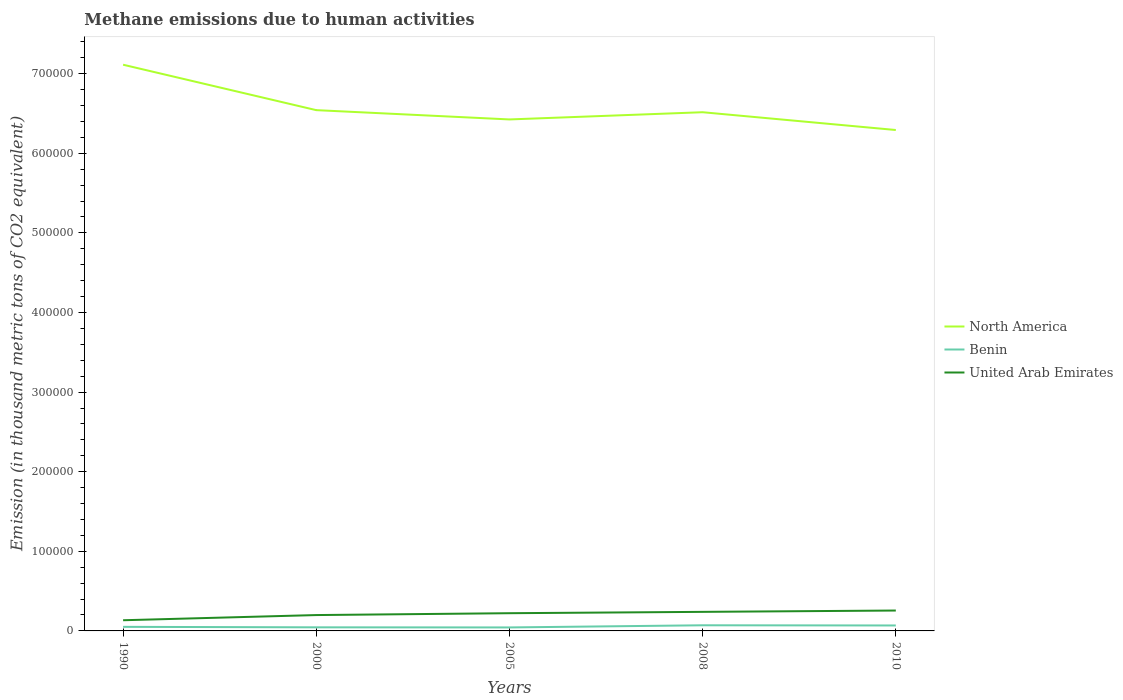How many different coloured lines are there?
Keep it short and to the point. 3. Does the line corresponding to United Arab Emirates intersect with the line corresponding to North America?
Keep it short and to the point. No. Is the number of lines equal to the number of legend labels?
Ensure brevity in your answer.  Yes. Across all years, what is the maximum amount of methane emitted in North America?
Provide a short and direct response. 6.29e+05. What is the total amount of methane emitted in United Arab Emirates in the graph?
Your response must be concise. -4025.9. What is the difference between the highest and the second highest amount of methane emitted in Benin?
Offer a terse response. 2709.3. What is the difference between the highest and the lowest amount of methane emitted in North America?
Your response must be concise. 1. How many lines are there?
Your response must be concise. 3. What is the difference between two consecutive major ticks on the Y-axis?
Give a very brief answer. 1.00e+05. Does the graph contain any zero values?
Offer a terse response. No. How are the legend labels stacked?
Provide a short and direct response. Vertical. What is the title of the graph?
Offer a very short reply. Methane emissions due to human activities. Does "Turkmenistan" appear as one of the legend labels in the graph?
Offer a terse response. No. What is the label or title of the X-axis?
Your response must be concise. Years. What is the label or title of the Y-axis?
Offer a terse response. Emission (in thousand metric tons of CO2 equivalent). What is the Emission (in thousand metric tons of CO2 equivalent) in North America in 1990?
Give a very brief answer. 7.11e+05. What is the Emission (in thousand metric tons of CO2 equivalent) in Benin in 1990?
Offer a very short reply. 5119.5. What is the Emission (in thousand metric tons of CO2 equivalent) of United Arab Emirates in 1990?
Make the answer very short. 1.34e+04. What is the Emission (in thousand metric tons of CO2 equivalent) of North America in 2000?
Your response must be concise. 6.54e+05. What is the Emission (in thousand metric tons of CO2 equivalent) in Benin in 2000?
Offer a very short reply. 4503.8. What is the Emission (in thousand metric tons of CO2 equivalent) in United Arab Emirates in 2000?
Your answer should be compact. 1.99e+04. What is the Emission (in thousand metric tons of CO2 equivalent) of North America in 2005?
Make the answer very short. 6.42e+05. What is the Emission (in thousand metric tons of CO2 equivalent) in Benin in 2005?
Your answer should be very brief. 4377.3. What is the Emission (in thousand metric tons of CO2 equivalent) of United Arab Emirates in 2005?
Keep it short and to the point. 2.23e+04. What is the Emission (in thousand metric tons of CO2 equivalent) of North America in 2008?
Offer a very short reply. 6.52e+05. What is the Emission (in thousand metric tons of CO2 equivalent) in Benin in 2008?
Offer a terse response. 7086.6. What is the Emission (in thousand metric tons of CO2 equivalent) of United Arab Emirates in 2008?
Offer a very short reply. 2.39e+04. What is the Emission (in thousand metric tons of CO2 equivalent) in North America in 2010?
Your answer should be compact. 6.29e+05. What is the Emission (in thousand metric tons of CO2 equivalent) of Benin in 2010?
Give a very brief answer. 6845.6. What is the Emission (in thousand metric tons of CO2 equivalent) of United Arab Emirates in 2010?
Your answer should be compact. 2.56e+04. Across all years, what is the maximum Emission (in thousand metric tons of CO2 equivalent) in North America?
Provide a short and direct response. 7.11e+05. Across all years, what is the maximum Emission (in thousand metric tons of CO2 equivalent) in Benin?
Make the answer very short. 7086.6. Across all years, what is the maximum Emission (in thousand metric tons of CO2 equivalent) of United Arab Emirates?
Keep it short and to the point. 2.56e+04. Across all years, what is the minimum Emission (in thousand metric tons of CO2 equivalent) of North America?
Keep it short and to the point. 6.29e+05. Across all years, what is the minimum Emission (in thousand metric tons of CO2 equivalent) in Benin?
Ensure brevity in your answer.  4377.3. Across all years, what is the minimum Emission (in thousand metric tons of CO2 equivalent) in United Arab Emirates?
Your response must be concise. 1.34e+04. What is the total Emission (in thousand metric tons of CO2 equivalent) of North America in the graph?
Provide a short and direct response. 3.29e+06. What is the total Emission (in thousand metric tons of CO2 equivalent) in Benin in the graph?
Your answer should be compact. 2.79e+04. What is the total Emission (in thousand metric tons of CO2 equivalent) of United Arab Emirates in the graph?
Offer a very short reply. 1.05e+05. What is the difference between the Emission (in thousand metric tons of CO2 equivalent) of North America in 1990 and that in 2000?
Your answer should be very brief. 5.71e+04. What is the difference between the Emission (in thousand metric tons of CO2 equivalent) of Benin in 1990 and that in 2000?
Provide a succinct answer. 615.7. What is the difference between the Emission (in thousand metric tons of CO2 equivalent) of United Arab Emirates in 1990 and that in 2000?
Offer a terse response. -6499. What is the difference between the Emission (in thousand metric tons of CO2 equivalent) in North America in 1990 and that in 2005?
Your response must be concise. 6.87e+04. What is the difference between the Emission (in thousand metric tons of CO2 equivalent) in Benin in 1990 and that in 2005?
Your answer should be very brief. 742.2. What is the difference between the Emission (in thousand metric tons of CO2 equivalent) of United Arab Emirates in 1990 and that in 2005?
Make the answer very short. -8841.4. What is the difference between the Emission (in thousand metric tons of CO2 equivalent) of North America in 1990 and that in 2008?
Give a very brief answer. 5.97e+04. What is the difference between the Emission (in thousand metric tons of CO2 equivalent) of Benin in 1990 and that in 2008?
Your answer should be compact. -1967.1. What is the difference between the Emission (in thousand metric tons of CO2 equivalent) in United Arab Emirates in 1990 and that in 2008?
Provide a short and direct response. -1.05e+04. What is the difference between the Emission (in thousand metric tons of CO2 equivalent) in North America in 1990 and that in 2010?
Give a very brief answer. 8.20e+04. What is the difference between the Emission (in thousand metric tons of CO2 equivalent) in Benin in 1990 and that in 2010?
Provide a short and direct response. -1726.1. What is the difference between the Emission (in thousand metric tons of CO2 equivalent) of United Arab Emirates in 1990 and that in 2010?
Ensure brevity in your answer.  -1.22e+04. What is the difference between the Emission (in thousand metric tons of CO2 equivalent) of North America in 2000 and that in 2005?
Provide a succinct answer. 1.17e+04. What is the difference between the Emission (in thousand metric tons of CO2 equivalent) in Benin in 2000 and that in 2005?
Your answer should be compact. 126.5. What is the difference between the Emission (in thousand metric tons of CO2 equivalent) in United Arab Emirates in 2000 and that in 2005?
Keep it short and to the point. -2342.4. What is the difference between the Emission (in thousand metric tons of CO2 equivalent) in North America in 2000 and that in 2008?
Make the answer very short. 2610. What is the difference between the Emission (in thousand metric tons of CO2 equivalent) in Benin in 2000 and that in 2008?
Offer a terse response. -2582.8. What is the difference between the Emission (in thousand metric tons of CO2 equivalent) of United Arab Emirates in 2000 and that in 2008?
Offer a terse response. -4025.9. What is the difference between the Emission (in thousand metric tons of CO2 equivalent) of North America in 2000 and that in 2010?
Your answer should be compact. 2.50e+04. What is the difference between the Emission (in thousand metric tons of CO2 equivalent) in Benin in 2000 and that in 2010?
Provide a succinct answer. -2341.8. What is the difference between the Emission (in thousand metric tons of CO2 equivalent) of United Arab Emirates in 2000 and that in 2010?
Provide a short and direct response. -5694.4. What is the difference between the Emission (in thousand metric tons of CO2 equivalent) in North America in 2005 and that in 2008?
Offer a very short reply. -9061.6. What is the difference between the Emission (in thousand metric tons of CO2 equivalent) of Benin in 2005 and that in 2008?
Make the answer very short. -2709.3. What is the difference between the Emission (in thousand metric tons of CO2 equivalent) of United Arab Emirates in 2005 and that in 2008?
Your response must be concise. -1683.5. What is the difference between the Emission (in thousand metric tons of CO2 equivalent) in North America in 2005 and that in 2010?
Your answer should be very brief. 1.33e+04. What is the difference between the Emission (in thousand metric tons of CO2 equivalent) in Benin in 2005 and that in 2010?
Provide a succinct answer. -2468.3. What is the difference between the Emission (in thousand metric tons of CO2 equivalent) in United Arab Emirates in 2005 and that in 2010?
Keep it short and to the point. -3352. What is the difference between the Emission (in thousand metric tons of CO2 equivalent) of North America in 2008 and that in 2010?
Provide a short and direct response. 2.23e+04. What is the difference between the Emission (in thousand metric tons of CO2 equivalent) of Benin in 2008 and that in 2010?
Ensure brevity in your answer.  241. What is the difference between the Emission (in thousand metric tons of CO2 equivalent) of United Arab Emirates in 2008 and that in 2010?
Offer a very short reply. -1668.5. What is the difference between the Emission (in thousand metric tons of CO2 equivalent) of North America in 1990 and the Emission (in thousand metric tons of CO2 equivalent) of Benin in 2000?
Ensure brevity in your answer.  7.07e+05. What is the difference between the Emission (in thousand metric tons of CO2 equivalent) of North America in 1990 and the Emission (in thousand metric tons of CO2 equivalent) of United Arab Emirates in 2000?
Provide a short and direct response. 6.91e+05. What is the difference between the Emission (in thousand metric tons of CO2 equivalent) of Benin in 1990 and the Emission (in thousand metric tons of CO2 equivalent) of United Arab Emirates in 2000?
Your answer should be very brief. -1.48e+04. What is the difference between the Emission (in thousand metric tons of CO2 equivalent) in North America in 1990 and the Emission (in thousand metric tons of CO2 equivalent) in Benin in 2005?
Provide a short and direct response. 7.07e+05. What is the difference between the Emission (in thousand metric tons of CO2 equivalent) in North America in 1990 and the Emission (in thousand metric tons of CO2 equivalent) in United Arab Emirates in 2005?
Offer a terse response. 6.89e+05. What is the difference between the Emission (in thousand metric tons of CO2 equivalent) in Benin in 1990 and the Emission (in thousand metric tons of CO2 equivalent) in United Arab Emirates in 2005?
Your answer should be very brief. -1.71e+04. What is the difference between the Emission (in thousand metric tons of CO2 equivalent) of North America in 1990 and the Emission (in thousand metric tons of CO2 equivalent) of Benin in 2008?
Keep it short and to the point. 7.04e+05. What is the difference between the Emission (in thousand metric tons of CO2 equivalent) of North America in 1990 and the Emission (in thousand metric tons of CO2 equivalent) of United Arab Emirates in 2008?
Your answer should be compact. 6.87e+05. What is the difference between the Emission (in thousand metric tons of CO2 equivalent) in Benin in 1990 and the Emission (in thousand metric tons of CO2 equivalent) in United Arab Emirates in 2008?
Your answer should be very brief. -1.88e+04. What is the difference between the Emission (in thousand metric tons of CO2 equivalent) in North America in 1990 and the Emission (in thousand metric tons of CO2 equivalent) in Benin in 2010?
Offer a very short reply. 7.04e+05. What is the difference between the Emission (in thousand metric tons of CO2 equivalent) in North America in 1990 and the Emission (in thousand metric tons of CO2 equivalent) in United Arab Emirates in 2010?
Offer a very short reply. 6.86e+05. What is the difference between the Emission (in thousand metric tons of CO2 equivalent) of Benin in 1990 and the Emission (in thousand metric tons of CO2 equivalent) of United Arab Emirates in 2010?
Offer a terse response. -2.05e+04. What is the difference between the Emission (in thousand metric tons of CO2 equivalent) of North America in 2000 and the Emission (in thousand metric tons of CO2 equivalent) of Benin in 2005?
Your response must be concise. 6.50e+05. What is the difference between the Emission (in thousand metric tons of CO2 equivalent) in North America in 2000 and the Emission (in thousand metric tons of CO2 equivalent) in United Arab Emirates in 2005?
Provide a succinct answer. 6.32e+05. What is the difference between the Emission (in thousand metric tons of CO2 equivalent) of Benin in 2000 and the Emission (in thousand metric tons of CO2 equivalent) of United Arab Emirates in 2005?
Offer a terse response. -1.78e+04. What is the difference between the Emission (in thousand metric tons of CO2 equivalent) in North America in 2000 and the Emission (in thousand metric tons of CO2 equivalent) in Benin in 2008?
Your response must be concise. 6.47e+05. What is the difference between the Emission (in thousand metric tons of CO2 equivalent) of North America in 2000 and the Emission (in thousand metric tons of CO2 equivalent) of United Arab Emirates in 2008?
Give a very brief answer. 6.30e+05. What is the difference between the Emission (in thousand metric tons of CO2 equivalent) in Benin in 2000 and the Emission (in thousand metric tons of CO2 equivalent) in United Arab Emirates in 2008?
Give a very brief answer. -1.94e+04. What is the difference between the Emission (in thousand metric tons of CO2 equivalent) of North America in 2000 and the Emission (in thousand metric tons of CO2 equivalent) of Benin in 2010?
Provide a short and direct response. 6.47e+05. What is the difference between the Emission (in thousand metric tons of CO2 equivalent) of North America in 2000 and the Emission (in thousand metric tons of CO2 equivalent) of United Arab Emirates in 2010?
Your response must be concise. 6.29e+05. What is the difference between the Emission (in thousand metric tons of CO2 equivalent) in Benin in 2000 and the Emission (in thousand metric tons of CO2 equivalent) in United Arab Emirates in 2010?
Your answer should be very brief. -2.11e+04. What is the difference between the Emission (in thousand metric tons of CO2 equivalent) of North America in 2005 and the Emission (in thousand metric tons of CO2 equivalent) of Benin in 2008?
Make the answer very short. 6.35e+05. What is the difference between the Emission (in thousand metric tons of CO2 equivalent) of North America in 2005 and the Emission (in thousand metric tons of CO2 equivalent) of United Arab Emirates in 2008?
Keep it short and to the point. 6.19e+05. What is the difference between the Emission (in thousand metric tons of CO2 equivalent) of Benin in 2005 and the Emission (in thousand metric tons of CO2 equivalent) of United Arab Emirates in 2008?
Keep it short and to the point. -1.96e+04. What is the difference between the Emission (in thousand metric tons of CO2 equivalent) of North America in 2005 and the Emission (in thousand metric tons of CO2 equivalent) of Benin in 2010?
Ensure brevity in your answer.  6.36e+05. What is the difference between the Emission (in thousand metric tons of CO2 equivalent) of North America in 2005 and the Emission (in thousand metric tons of CO2 equivalent) of United Arab Emirates in 2010?
Your response must be concise. 6.17e+05. What is the difference between the Emission (in thousand metric tons of CO2 equivalent) of Benin in 2005 and the Emission (in thousand metric tons of CO2 equivalent) of United Arab Emirates in 2010?
Ensure brevity in your answer.  -2.12e+04. What is the difference between the Emission (in thousand metric tons of CO2 equivalent) in North America in 2008 and the Emission (in thousand metric tons of CO2 equivalent) in Benin in 2010?
Ensure brevity in your answer.  6.45e+05. What is the difference between the Emission (in thousand metric tons of CO2 equivalent) of North America in 2008 and the Emission (in thousand metric tons of CO2 equivalent) of United Arab Emirates in 2010?
Your response must be concise. 6.26e+05. What is the difference between the Emission (in thousand metric tons of CO2 equivalent) in Benin in 2008 and the Emission (in thousand metric tons of CO2 equivalent) in United Arab Emirates in 2010?
Give a very brief answer. -1.85e+04. What is the average Emission (in thousand metric tons of CO2 equivalent) in North America per year?
Provide a short and direct response. 6.58e+05. What is the average Emission (in thousand metric tons of CO2 equivalent) of Benin per year?
Keep it short and to the point. 5586.56. What is the average Emission (in thousand metric tons of CO2 equivalent) in United Arab Emirates per year?
Your answer should be very brief. 2.10e+04. In the year 1990, what is the difference between the Emission (in thousand metric tons of CO2 equivalent) of North America and Emission (in thousand metric tons of CO2 equivalent) of Benin?
Give a very brief answer. 7.06e+05. In the year 1990, what is the difference between the Emission (in thousand metric tons of CO2 equivalent) of North America and Emission (in thousand metric tons of CO2 equivalent) of United Arab Emirates?
Provide a short and direct response. 6.98e+05. In the year 1990, what is the difference between the Emission (in thousand metric tons of CO2 equivalent) in Benin and Emission (in thousand metric tons of CO2 equivalent) in United Arab Emirates?
Offer a very short reply. -8294.7. In the year 2000, what is the difference between the Emission (in thousand metric tons of CO2 equivalent) in North America and Emission (in thousand metric tons of CO2 equivalent) in Benin?
Your answer should be compact. 6.50e+05. In the year 2000, what is the difference between the Emission (in thousand metric tons of CO2 equivalent) of North America and Emission (in thousand metric tons of CO2 equivalent) of United Arab Emirates?
Your answer should be very brief. 6.34e+05. In the year 2000, what is the difference between the Emission (in thousand metric tons of CO2 equivalent) in Benin and Emission (in thousand metric tons of CO2 equivalent) in United Arab Emirates?
Give a very brief answer. -1.54e+04. In the year 2005, what is the difference between the Emission (in thousand metric tons of CO2 equivalent) of North America and Emission (in thousand metric tons of CO2 equivalent) of Benin?
Ensure brevity in your answer.  6.38e+05. In the year 2005, what is the difference between the Emission (in thousand metric tons of CO2 equivalent) of North America and Emission (in thousand metric tons of CO2 equivalent) of United Arab Emirates?
Your response must be concise. 6.20e+05. In the year 2005, what is the difference between the Emission (in thousand metric tons of CO2 equivalent) in Benin and Emission (in thousand metric tons of CO2 equivalent) in United Arab Emirates?
Make the answer very short. -1.79e+04. In the year 2008, what is the difference between the Emission (in thousand metric tons of CO2 equivalent) of North America and Emission (in thousand metric tons of CO2 equivalent) of Benin?
Make the answer very short. 6.44e+05. In the year 2008, what is the difference between the Emission (in thousand metric tons of CO2 equivalent) in North America and Emission (in thousand metric tons of CO2 equivalent) in United Arab Emirates?
Offer a terse response. 6.28e+05. In the year 2008, what is the difference between the Emission (in thousand metric tons of CO2 equivalent) in Benin and Emission (in thousand metric tons of CO2 equivalent) in United Arab Emirates?
Ensure brevity in your answer.  -1.69e+04. In the year 2010, what is the difference between the Emission (in thousand metric tons of CO2 equivalent) of North America and Emission (in thousand metric tons of CO2 equivalent) of Benin?
Give a very brief answer. 6.22e+05. In the year 2010, what is the difference between the Emission (in thousand metric tons of CO2 equivalent) in North America and Emission (in thousand metric tons of CO2 equivalent) in United Arab Emirates?
Ensure brevity in your answer.  6.04e+05. In the year 2010, what is the difference between the Emission (in thousand metric tons of CO2 equivalent) of Benin and Emission (in thousand metric tons of CO2 equivalent) of United Arab Emirates?
Your answer should be very brief. -1.88e+04. What is the ratio of the Emission (in thousand metric tons of CO2 equivalent) of North America in 1990 to that in 2000?
Ensure brevity in your answer.  1.09. What is the ratio of the Emission (in thousand metric tons of CO2 equivalent) of Benin in 1990 to that in 2000?
Give a very brief answer. 1.14. What is the ratio of the Emission (in thousand metric tons of CO2 equivalent) in United Arab Emirates in 1990 to that in 2000?
Ensure brevity in your answer.  0.67. What is the ratio of the Emission (in thousand metric tons of CO2 equivalent) of North America in 1990 to that in 2005?
Offer a very short reply. 1.11. What is the ratio of the Emission (in thousand metric tons of CO2 equivalent) of Benin in 1990 to that in 2005?
Your answer should be very brief. 1.17. What is the ratio of the Emission (in thousand metric tons of CO2 equivalent) in United Arab Emirates in 1990 to that in 2005?
Provide a short and direct response. 0.6. What is the ratio of the Emission (in thousand metric tons of CO2 equivalent) of North America in 1990 to that in 2008?
Ensure brevity in your answer.  1.09. What is the ratio of the Emission (in thousand metric tons of CO2 equivalent) of Benin in 1990 to that in 2008?
Your answer should be very brief. 0.72. What is the ratio of the Emission (in thousand metric tons of CO2 equivalent) of United Arab Emirates in 1990 to that in 2008?
Provide a short and direct response. 0.56. What is the ratio of the Emission (in thousand metric tons of CO2 equivalent) in North America in 1990 to that in 2010?
Your answer should be compact. 1.13. What is the ratio of the Emission (in thousand metric tons of CO2 equivalent) in Benin in 1990 to that in 2010?
Your answer should be very brief. 0.75. What is the ratio of the Emission (in thousand metric tons of CO2 equivalent) in United Arab Emirates in 1990 to that in 2010?
Your answer should be very brief. 0.52. What is the ratio of the Emission (in thousand metric tons of CO2 equivalent) of North America in 2000 to that in 2005?
Offer a terse response. 1.02. What is the ratio of the Emission (in thousand metric tons of CO2 equivalent) of Benin in 2000 to that in 2005?
Give a very brief answer. 1.03. What is the ratio of the Emission (in thousand metric tons of CO2 equivalent) of United Arab Emirates in 2000 to that in 2005?
Make the answer very short. 0.89. What is the ratio of the Emission (in thousand metric tons of CO2 equivalent) in Benin in 2000 to that in 2008?
Ensure brevity in your answer.  0.64. What is the ratio of the Emission (in thousand metric tons of CO2 equivalent) in United Arab Emirates in 2000 to that in 2008?
Keep it short and to the point. 0.83. What is the ratio of the Emission (in thousand metric tons of CO2 equivalent) in North America in 2000 to that in 2010?
Offer a very short reply. 1.04. What is the ratio of the Emission (in thousand metric tons of CO2 equivalent) in Benin in 2000 to that in 2010?
Keep it short and to the point. 0.66. What is the ratio of the Emission (in thousand metric tons of CO2 equivalent) in United Arab Emirates in 2000 to that in 2010?
Your answer should be compact. 0.78. What is the ratio of the Emission (in thousand metric tons of CO2 equivalent) of North America in 2005 to that in 2008?
Your response must be concise. 0.99. What is the ratio of the Emission (in thousand metric tons of CO2 equivalent) in Benin in 2005 to that in 2008?
Provide a succinct answer. 0.62. What is the ratio of the Emission (in thousand metric tons of CO2 equivalent) in United Arab Emirates in 2005 to that in 2008?
Offer a very short reply. 0.93. What is the ratio of the Emission (in thousand metric tons of CO2 equivalent) in North America in 2005 to that in 2010?
Your response must be concise. 1.02. What is the ratio of the Emission (in thousand metric tons of CO2 equivalent) of Benin in 2005 to that in 2010?
Keep it short and to the point. 0.64. What is the ratio of the Emission (in thousand metric tons of CO2 equivalent) in United Arab Emirates in 2005 to that in 2010?
Your answer should be very brief. 0.87. What is the ratio of the Emission (in thousand metric tons of CO2 equivalent) in North America in 2008 to that in 2010?
Your answer should be compact. 1.04. What is the ratio of the Emission (in thousand metric tons of CO2 equivalent) of Benin in 2008 to that in 2010?
Provide a short and direct response. 1.04. What is the ratio of the Emission (in thousand metric tons of CO2 equivalent) of United Arab Emirates in 2008 to that in 2010?
Keep it short and to the point. 0.93. What is the difference between the highest and the second highest Emission (in thousand metric tons of CO2 equivalent) in North America?
Make the answer very short. 5.71e+04. What is the difference between the highest and the second highest Emission (in thousand metric tons of CO2 equivalent) of Benin?
Keep it short and to the point. 241. What is the difference between the highest and the second highest Emission (in thousand metric tons of CO2 equivalent) in United Arab Emirates?
Provide a short and direct response. 1668.5. What is the difference between the highest and the lowest Emission (in thousand metric tons of CO2 equivalent) in North America?
Your answer should be very brief. 8.20e+04. What is the difference between the highest and the lowest Emission (in thousand metric tons of CO2 equivalent) of Benin?
Offer a very short reply. 2709.3. What is the difference between the highest and the lowest Emission (in thousand metric tons of CO2 equivalent) in United Arab Emirates?
Make the answer very short. 1.22e+04. 